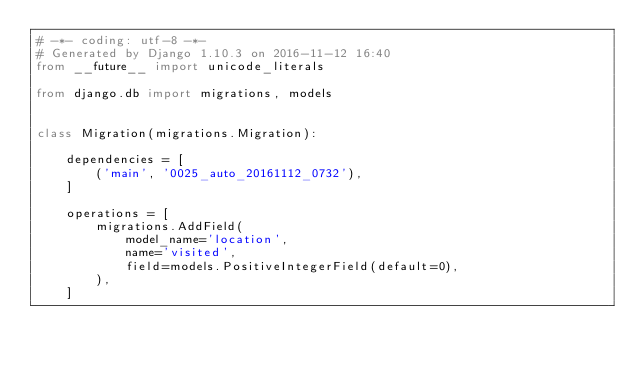Convert code to text. <code><loc_0><loc_0><loc_500><loc_500><_Python_># -*- coding: utf-8 -*-
# Generated by Django 1.10.3 on 2016-11-12 16:40
from __future__ import unicode_literals

from django.db import migrations, models


class Migration(migrations.Migration):

    dependencies = [
        ('main', '0025_auto_20161112_0732'),
    ]

    operations = [
        migrations.AddField(
            model_name='location',
            name='visited',
            field=models.PositiveIntegerField(default=0),
        ),
    ]
</code> 